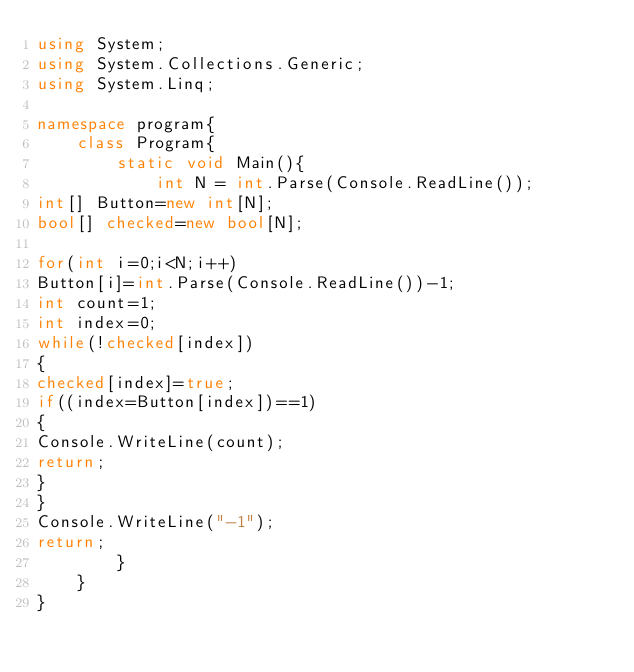Convert code to text. <code><loc_0><loc_0><loc_500><loc_500><_C#_>using System;
using System.Collections.Generic;
using System.Linq;

namespace program{
	class Program{
		static void Main(){
			int N = int.Parse(Console.ReadLine());
int[] Button=new int[N];
bool[] checked=new bool[N];

for(int i=0;i<N;i++)
Button[i]=int.Parse(Console.ReadLine())-1;
int count=1;
int index=0;
while(!checked[index])
{
checked[index]=true;
if((index=Button[index])==1)
{
Console.WriteLine(count);
return;
}
}
Console.WriteLine("-1");
return;
		}
	}
}

</code> 